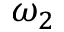Convert formula to latex. <formula><loc_0><loc_0><loc_500><loc_500>\omega _ { 2 }</formula> 